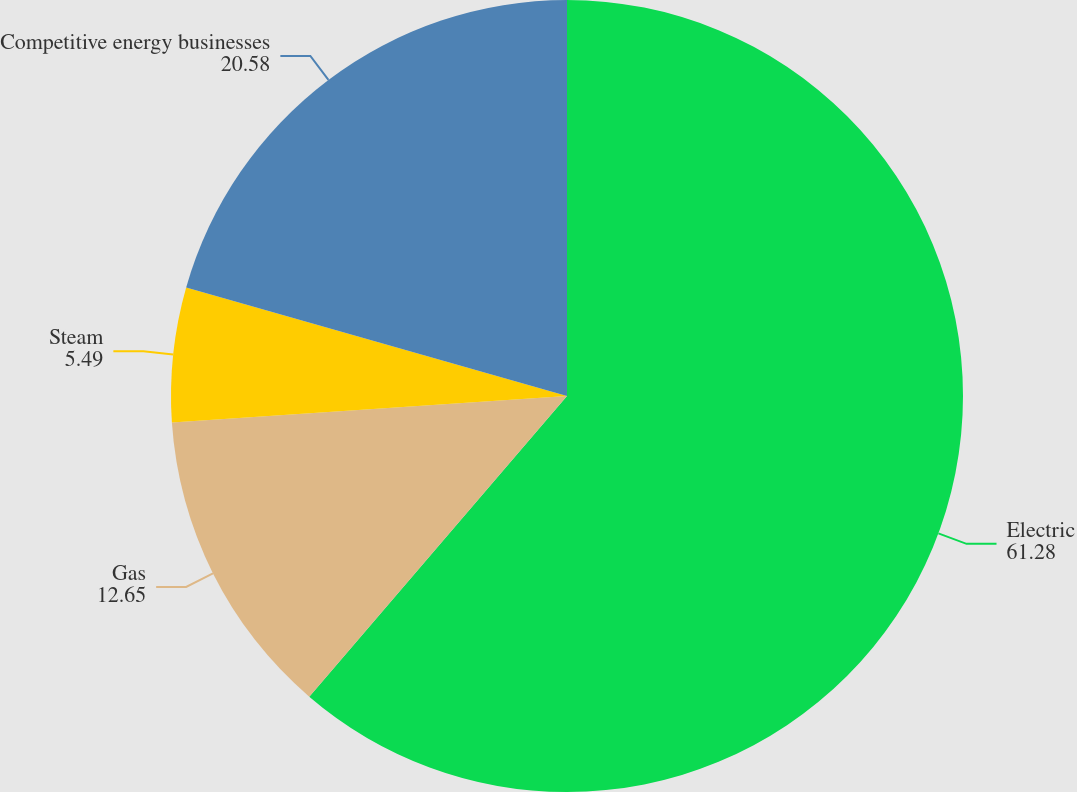Convert chart to OTSL. <chart><loc_0><loc_0><loc_500><loc_500><pie_chart><fcel>Electric<fcel>Gas<fcel>Steam<fcel>Competitive energy businesses<nl><fcel>61.28%<fcel>12.65%<fcel>5.49%<fcel>20.58%<nl></chart> 